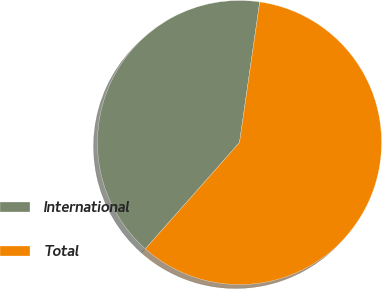<chart> <loc_0><loc_0><loc_500><loc_500><pie_chart><fcel>International<fcel>Total<nl><fcel>40.74%<fcel>59.26%<nl></chart> 